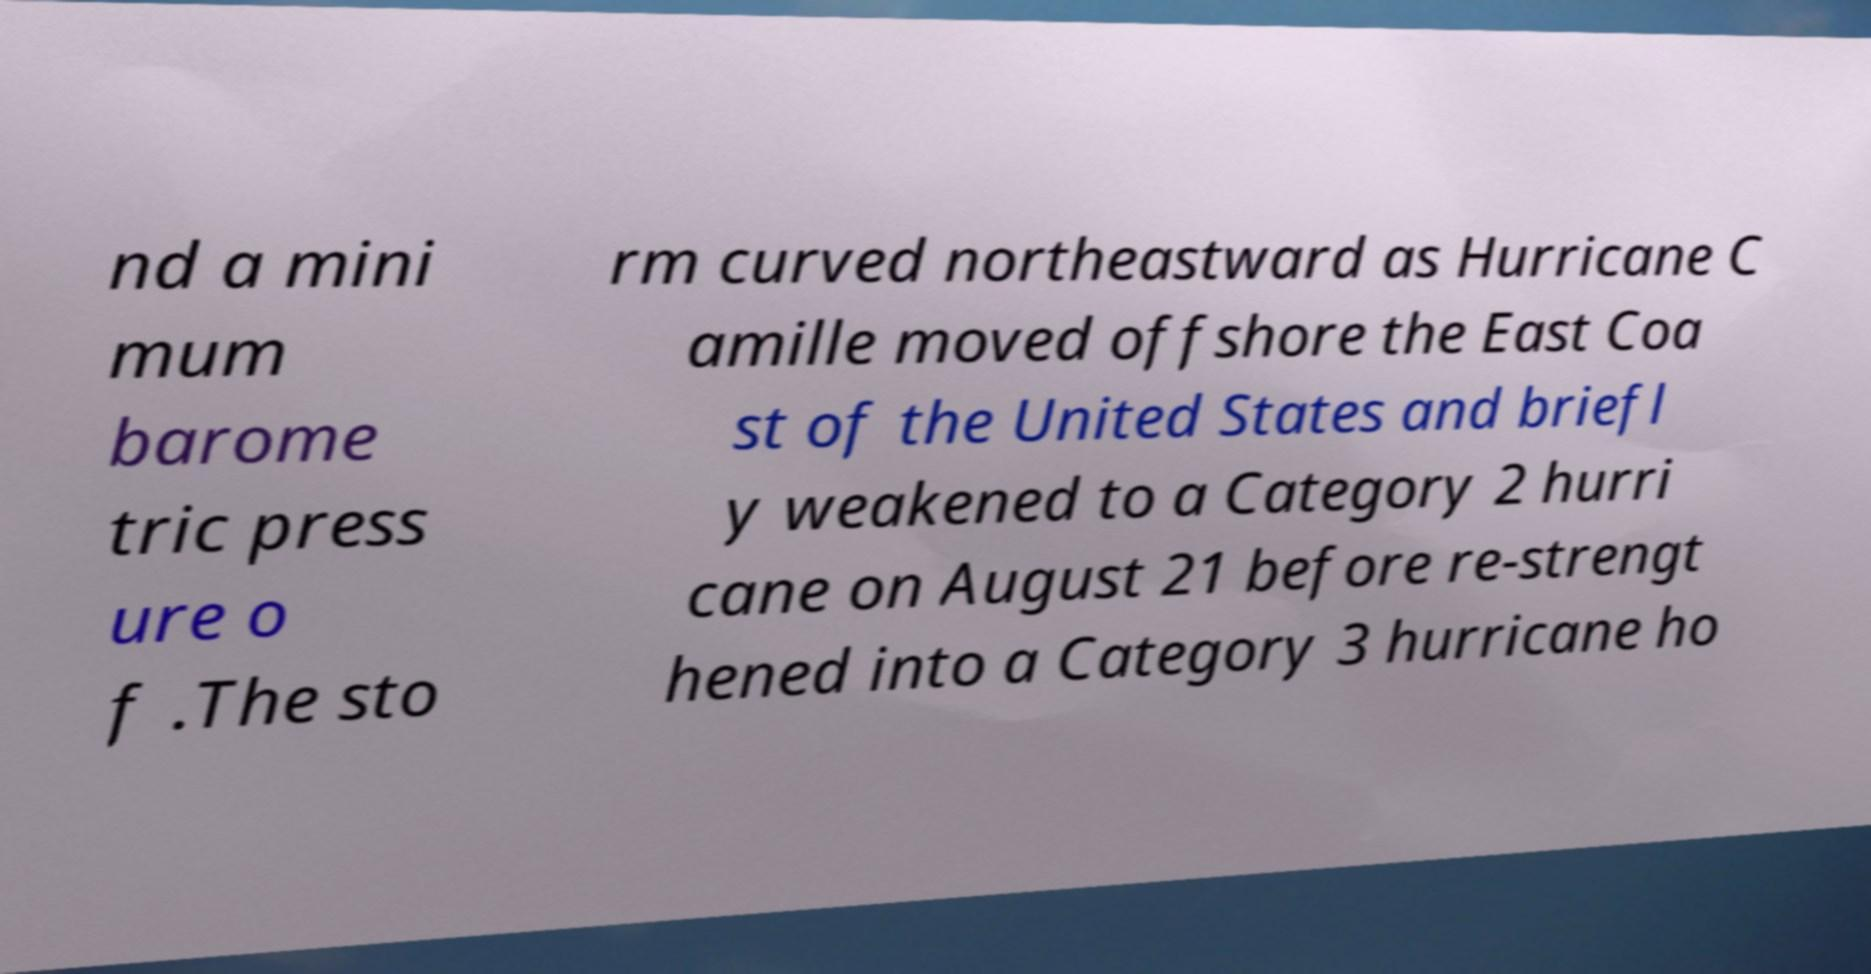Could you extract and type out the text from this image? nd a mini mum barome tric press ure o f .The sto rm curved northeastward as Hurricane C amille moved offshore the East Coa st of the United States and briefl y weakened to a Category 2 hurri cane on August 21 before re-strengt hened into a Category 3 hurricane ho 